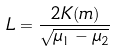Convert formula to latex. <formula><loc_0><loc_0><loc_500><loc_500>L = \frac { 2 K ( m ) } { \sqrt { \mu _ { 1 } - \mu _ { 2 } } }</formula> 